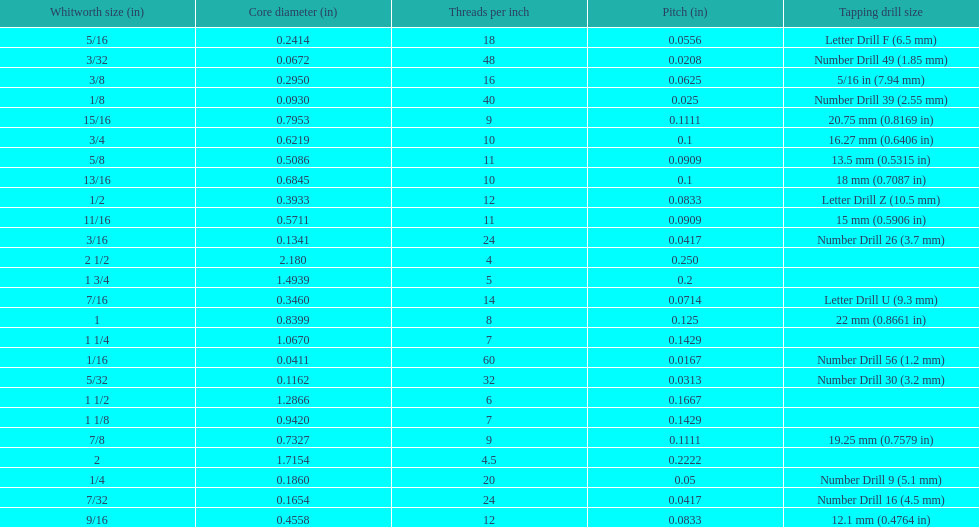Which whitworth size has the same number of threads per inch as 3/16? 7/32. 